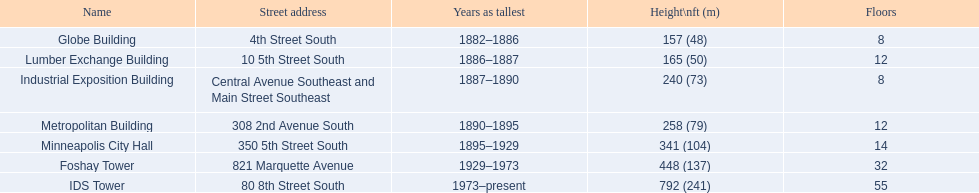In which years was a height of 240 ft deemed tall? 1887–1890. Which structure held this distinction? Industrial Exposition Building. 